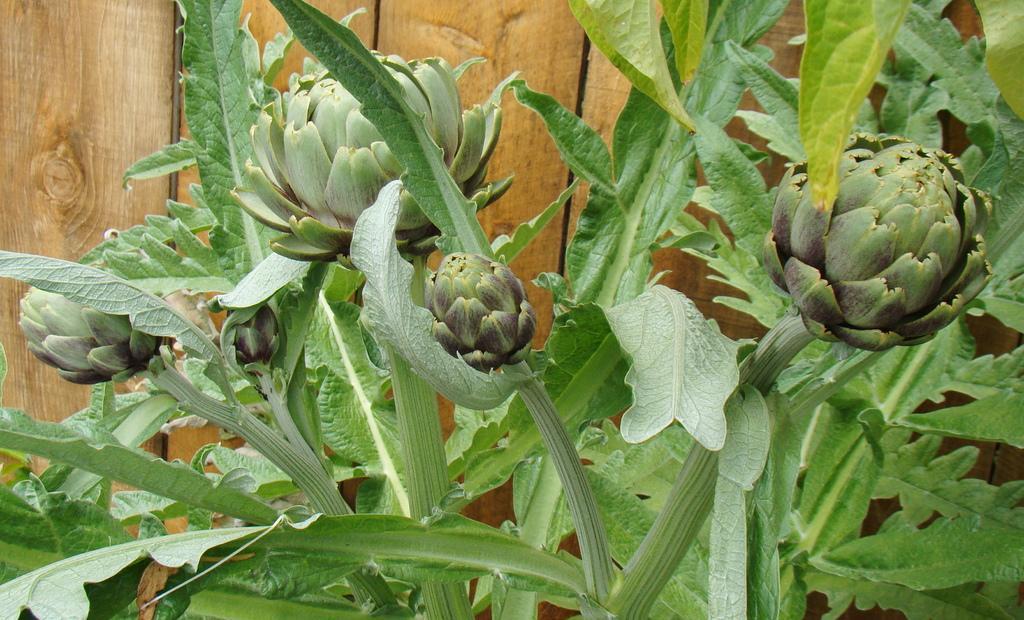Can you describe this image briefly? In this picture we can see a few green flowers and leaves. There is a wooden object in the background. 